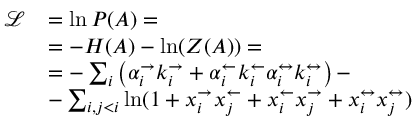<formula> <loc_0><loc_0><loc_500><loc_500>\begin{array} { r l } { \mathcal { L } } & { = \ln P ( A ) = } \\ & { = - H ( A ) - \ln ( Z ( A ) ) = } \\ & { = - \sum _ { i } \left ( \alpha _ { i } ^ { \rightarrow } k _ { i } ^ { \rightarrow } + \alpha _ { i } ^ { \leftarrow } k _ { i } ^ { \leftarrow } \alpha _ { i } ^ { \leftrightarrow } k _ { i } ^ { \leftrightarrow } \right ) - } \\ & { - \sum _ { i , j < i } \ln ( 1 + x _ { i } ^ { \rightarrow } x _ { j } ^ { \leftarrow } + x _ { i } ^ { \leftarrow } x _ { j } ^ { \rightarrow } + x _ { i } ^ { \leftrightarrow } x _ { j } ^ { \leftrightarrow } ) } \end{array}</formula> 